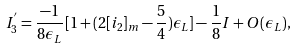Convert formula to latex. <formula><loc_0><loc_0><loc_500><loc_500>I _ { 3 } ^ { ^ { \prime } } = \frac { - 1 } { 8 \epsilon _ { L } } [ 1 + ( 2 [ i _ { 2 } ] _ { m } - \frac { 5 } { 4 } ) \epsilon _ { L } ] - \frac { 1 } { 8 } I + O ( \epsilon _ { L } ) ,</formula> 